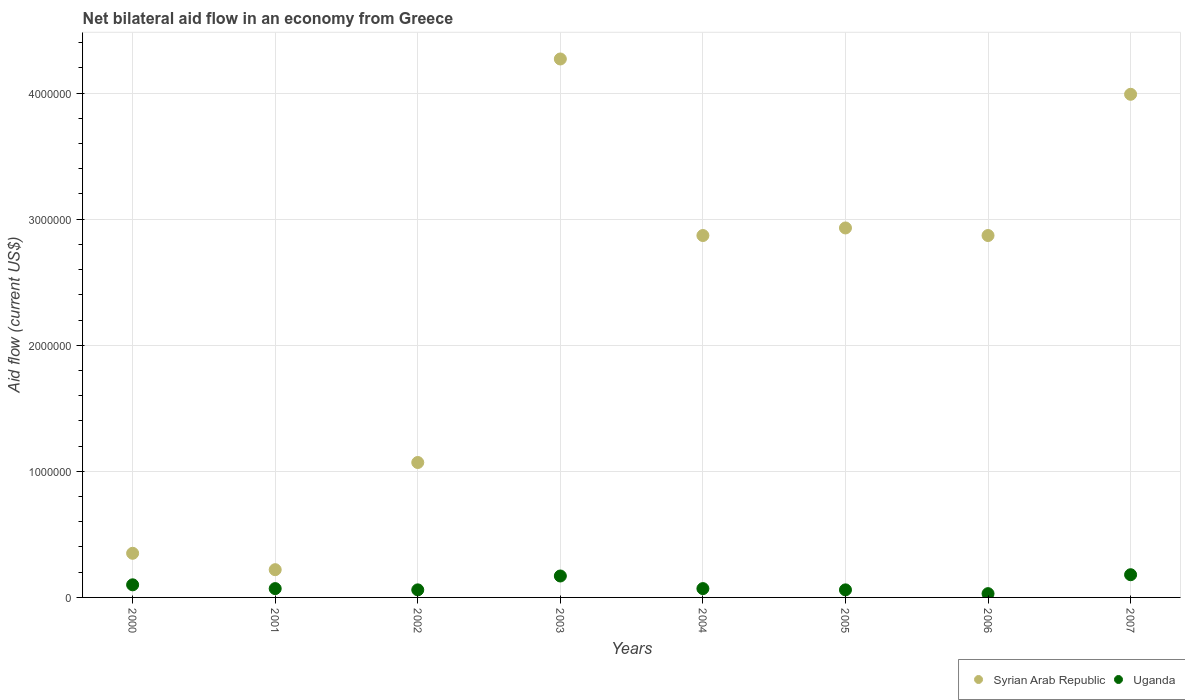How many different coloured dotlines are there?
Give a very brief answer. 2. What is the net bilateral aid flow in Syrian Arab Republic in 2007?
Ensure brevity in your answer.  3.99e+06. Across all years, what is the maximum net bilateral aid flow in Uganda?
Provide a short and direct response. 1.80e+05. In which year was the net bilateral aid flow in Uganda maximum?
Give a very brief answer. 2007. What is the total net bilateral aid flow in Syrian Arab Republic in the graph?
Keep it short and to the point. 1.86e+07. What is the difference between the net bilateral aid flow in Uganda in 2000 and that in 2002?
Ensure brevity in your answer.  4.00e+04. What is the difference between the net bilateral aid flow in Uganda in 2002 and the net bilateral aid flow in Syrian Arab Republic in 2003?
Give a very brief answer. -4.21e+06. What is the average net bilateral aid flow in Uganda per year?
Make the answer very short. 9.25e+04. In the year 2003, what is the difference between the net bilateral aid flow in Uganda and net bilateral aid flow in Syrian Arab Republic?
Offer a terse response. -4.10e+06. In how many years, is the net bilateral aid flow in Syrian Arab Republic greater than 3600000 US$?
Offer a terse response. 2. What is the ratio of the net bilateral aid flow in Syrian Arab Republic in 2005 to that in 2007?
Offer a very short reply. 0.73. Is the net bilateral aid flow in Syrian Arab Republic in 2004 less than that in 2006?
Offer a very short reply. No. What is the difference between the highest and the lowest net bilateral aid flow in Syrian Arab Republic?
Provide a short and direct response. 4.05e+06. Is the sum of the net bilateral aid flow in Syrian Arab Republic in 2004 and 2005 greater than the maximum net bilateral aid flow in Uganda across all years?
Keep it short and to the point. Yes. Are the values on the major ticks of Y-axis written in scientific E-notation?
Keep it short and to the point. No. Does the graph contain any zero values?
Ensure brevity in your answer.  No. Where does the legend appear in the graph?
Your answer should be compact. Bottom right. What is the title of the graph?
Keep it short and to the point. Net bilateral aid flow in an economy from Greece. What is the label or title of the Y-axis?
Your answer should be compact. Aid flow (current US$). What is the Aid flow (current US$) in Syrian Arab Republic in 2000?
Ensure brevity in your answer.  3.50e+05. What is the Aid flow (current US$) in Uganda in 2000?
Make the answer very short. 1.00e+05. What is the Aid flow (current US$) of Uganda in 2001?
Your answer should be compact. 7.00e+04. What is the Aid flow (current US$) of Syrian Arab Republic in 2002?
Give a very brief answer. 1.07e+06. What is the Aid flow (current US$) in Syrian Arab Republic in 2003?
Offer a terse response. 4.27e+06. What is the Aid flow (current US$) of Syrian Arab Republic in 2004?
Give a very brief answer. 2.87e+06. What is the Aid flow (current US$) in Uganda in 2004?
Provide a succinct answer. 7.00e+04. What is the Aid flow (current US$) of Syrian Arab Republic in 2005?
Provide a short and direct response. 2.93e+06. What is the Aid flow (current US$) of Syrian Arab Republic in 2006?
Make the answer very short. 2.87e+06. What is the Aid flow (current US$) of Syrian Arab Republic in 2007?
Give a very brief answer. 3.99e+06. Across all years, what is the maximum Aid flow (current US$) in Syrian Arab Republic?
Provide a succinct answer. 4.27e+06. Across all years, what is the minimum Aid flow (current US$) in Syrian Arab Republic?
Offer a very short reply. 2.20e+05. Across all years, what is the minimum Aid flow (current US$) of Uganda?
Provide a short and direct response. 3.00e+04. What is the total Aid flow (current US$) of Syrian Arab Republic in the graph?
Offer a very short reply. 1.86e+07. What is the total Aid flow (current US$) in Uganda in the graph?
Provide a succinct answer. 7.40e+05. What is the difference between the Aid flow (current US$) of Syrian Arab Republic in 2000 and that in 2002?
Your response must be concise. -7.20e+05. What is the difference between the Aid flow (current US$) in Uganda in 2000 and that in 2002?
Give a very brief answer. 4.00e+04. What is the difference between the Aid flow (current US$) of Syrian Arab Republic in 2000 and that in 2003?
Give a very brief answer. -3.92e+06. What is the difference between the Aid flow (current US$) of Uganda in 2000 and that in 2003?
Your response must be concise. -7.00e+04. What is the difference between the Aid flow (current US$) of Syrian Arab Republic in 2000 and that in 2004?
Keep it short and to the point. -2.52e+06. What is the difference between the Aid flow (current US$) of Syrian Arab Republic in 2000 and that in 2005?
Offer a terse response. -2.58e+06. What is the difference between the Aid flow (current US$) of Syrian Arab Republic in 2000 and that in 2006?
Make the answer very short. -2.52e+06. What is the difference between the Aid flow (current US$) of Syrian Arab Republic in 2000 and that in 2007?
Your response must be concise. -3.64e+06. What is the difference between the Aid flow (current US$) of Uganda in 2000 and that in 2007?
Your response must be concise. -8.00e+04. What is the difference between the Aid flow (current US$) of Syrian Arab Republic in 2001 and that in 2002?
Offer a very short reply. -8.50e+05. What is the difference between the Aid flow (current US$) of Uganda in 2001 and that in 2002?
Offer a very short reply. 10000. What is the difference between the Aid flow (current US$) of Syrian Arab Republic in 2001 and that in 2003?
Provide a succinct answer. -4.05e+06. What is the difference between the Aid flow (current US$) in Uganda in 2001 and that in 2003?
Offer a very short reply. -1.00e+05. What is the difference between the Aid flow (current US$) in Syrian Arab Republic in 2001 and that in 2004?
Make the answer very short. -2.65e+06. What is the difference between the Aid flow (current US$) in Syrian Arab Republic in 2001 and that in 2005?
Your answer should be compact. -2.71e+06. What is the difference between the Aid flow (current US$) in Syrian Arab Republic in 2001 and that in 2006?
Make the answer very short. -2.65e+06. What is the difference between the Aid flow (current US$) in Syrian Arab Republic in 2001 and that in 2007?
Provide a short and direct response. -3.77e+06. What is the difference between the Aid flow (current US$) in Uganda in 2001 and that in 2007?
Offer a very short reply. -1.10e+05. What is the difference between the Aid flow (current US$) of Syrian Arab Republic in 2002 and that in 2003?
Provide a short and direct response. -3.20e+06. What is the difference between the Aid flow (current US$) in Syrian Arab Republic in 2002 and that in 2004?
Ensure brevity in your answer.  -1.80e+06. What is the difference between the Aid flow (current US$) in Uganda in 2002 and that in 2004?
Keep it short and to the point. -10000. What is the difference between the Aid flow (current US$) in Syrian Arab Republic in 2002 and that in 2005?
Your answer should be very brief. -1.86e+06. What is the difference between the Aid flow (current US$) in Uganda in 2002 and that in 2005?
Your answer should be compact. 0. What is the difference between the Aid flow (current US$) in Syrian Arab Republic in 2002 and that in 2006?
Make the answer very short. -1.80e+06. What is the difference between the Aid flow (current US$) in Syrian Arab Republic in 2002 and that in 2007?
Your answer should be very brief. -2.92e+06. What is the difference between the Aid flow (current US$) of Syrian Arab Republic in 2003 and that in 2004?
Offer a terse response. 1.40e+06. What is the difference between the Aid flow (current US$) in Syrian Arab Republic in 2003 and that in 2005?
Offer a very short reply. 1.34e+06. What is the difference between the Aid flow (current US$) in Syrian Arab Republic in 2003 and that in 2006?
Offer a very short reply. 1.40e+06. What is the difference between the Aid flow (current US$) of Uganda in 2003 and that in 2007?
Ensure brevity in your answer.  -10000. What is the difference between the Aid flow (current US$) in Uganda in 2004 and that in 2005?
Offer a very short reply. 10000. What is the difference between the Aid flow (current US$) of Syrian Arab Republic in 2004 and that in 2006?
Your answer should be very brief. 0. What is the difference between the Aid flow (current US$) in Syrian Arab Republic in 2004 and that in 2007?
Provide a succinct answer. -1.12e+06. What is the difference between the Aid flow (current US$) of Uganda in 2004 and that in 2007?
Your answer should be very brief. -1.10e+05. What is the difference between the Aid flow (current US$) in Syrian Arab Republic in 2005 and that in 2007?
Your response must be concise. -1.06e+06. What is the difference between the Aid flow (current US$) of Uganda in 2005 and that in 2007?
Ensure brevity in your answer.  -1.20e+05. What is the difference between the Aid flow (current US$) of Syrian Arab Republic in 2006 and that in 2007?
Provide a succinct answer. -1.12e+06. What is the difference between the Aid flow (current US$) of Syrian Arab Republic in 2000 and the Aid flow (current US$) of Uganda in 2007?
Keep it short and to the point. 1.70e+05. What is the difference between the Aid flow (current US$) in Syrian Arab Republic in 2001 and the Aid flow (current US$) in Uganda in 2003?
Give a very brief answer. 5.00e+04. What is the difference between the Aid flow (current US$) in Syrian Arab Republic in 2001 and the Aid flow (current US$) in Uganda in 2005?
Give a very brief answer. 1.60e+05. What is the difference between the Aid flow (current US$) of Syrian Arab Republic in 2001 and the Aid flow (current US$) of Uganda in 2006?
Offer a very short reply. 1.90e+05. What is the difference between the Aid flow (current US$) of Syrian Arab Republic in 2001 and the Aid flow (current US$) of Uganda in 2007?
Keep it short and to the point. 4.00e+04. What is the difference between the Aid flow (current US$) in Syrian Arab Republic in 2002 and the Aid flow (current US$) in Uganda in 2005?
Your answer should be compact. 1.01e+06. What is the difference between the Aid flow (current US$) in Syrian Arab Republic in 2002 and the Aid flow (current US$) in Uganda in 2006?
Your answer should be compact. 1.04e+06. What is the difference between the Aid flow (current US$) of Syrian Arab Republic in 2002 and the Aid flow (current US$) of Uganda in 2007?
Provide a succinct answer. 8.90e+05. What is the difference between the Aid flow (current US$) in Syrian Arab Republic in 2003 and the Aid flow (current US$) in Uganda in 2004?
Make the answer very short. 4.20e+06. What is the difference between the Aid flow (current US$) of Syrian Arab Republic in 2003 and the Aid flow (current US$) of Uganda in 2005?
Give a very brief answer. 4.21e+06. What is the difference between the Aid flow (current US$) in Syrian Arab Republic in 2003 and the Aid flow (current US$) in Uganda in 2006?
Your response must be concise. 4.24e+06. What is the difference between the Aid flow (current US$) in Syrian Arab Republic in 2003 and the Aid flow (current US$) in Uganda in 2007?
Your answer should be compact. 4.09e+06. What is the difference between the Aid flow (current US$) in Syrian Arab Republic in 2004 and the Aid flow (current US$) in Uganda in 2005?
Ensure brevity in your answer.  2.81e+06. What is the difference between the Aid flow (current US$) in Syrian Arab Republic in 2004 and the Aid flow (current US$) in Uganda in 2006?
Offer a very short reply. 2.84e+06. What is the difference between the Aid flow (current US$) of Syrian Arab Republic in 2004 and the Aid flow (current US$) of Uganda in 2007?
Ensure brevity in your answer.  2.69e+06. What is the difference between the Aid flow (current US$) in Syrian Arab Republic in 2005 and the Aid flow (current US$) in Uganda in 2006?
Ensure brevity in your answer.  2.90e+06. What is the difference between the Aid flow (current US$) in Syrian Arab Republic in 2005 and the Aid flow (current US$) in Uganda in 2007?
Give a very brief answer. 2.75e+06. What is the difference between the Aid flow (current US$) in Syrian Arab Republic in 2006 and the Aid flow (current US$) in Uganda in 2007?
Keep it short and to the point. 2.69e+06. What is the average Aid flow (current US$) of Syrian Arab Republic per year?
Your answer should be compact. 2.32e+06. What is the average Aid flow (current US$) in Uganda per year?
Your response must be concise. 9.25e+04. In the year 2000, what is the difference between the Aid flow (current US$) of Syrian Arab Republic and Aid flow (current US$) of Uganda?
Offer a terse response. 2.50e+05. In the year 2002, what is the difference between the Aid flow (current US$) in Syrian Arab Republic and Aid flow (current US$) in Uganda?
Your answer should be compact. 1.01e+06. In the year 2003, what is the difference between the Aid flow (current US$) in Syrian Arab Republic and Aid flow (current US$) in Uganda?
Provide a short and direct response. 4.10e+06. In the year 2004, what is the difference between the Aid flow (current US$) in Syrian Arab Republic and Aid flow (current US$) in Uganda?
Provide a short and direct response. 2.80e+06. In the year 2005, what is the difference between the Aid flow (current US$) of Syrian Arab Republic and Aid flow (current US$) of Uganda?
Provide a succinct answer. 2.87e+06. In the year 2006, what is the difference between the Aid flow (current US$) of Syrian Arab Republic and Aid flow (current US$) of Uganda?
Keep it short and to the point. 2.84e+06. In the year 2007, what is the difference between the Aid flow (current US$) of Syrian Arab Republic and Aid flow (current US$) of Uganda?
Your response must be concise. 3.81e+06. What is the ratio of the Aid flow (current US$) of Syrian Arab Republic in 2000 to that in 2001?
Ensure brevity in your answer.  1.59. What is the ratio of the Aid flow (current US$) of Uganda in 2000 to that in 2001?
Offer a very short reply. 1.43. What is the ratio of the Aid flow (current US$) in Syrian Arab Republic in 2000 to that in 2002?
Keep it short and to the point. 0.33. What is the ratio of the Aid flow (current US$) in Uganda in 2000 to that in 2002?
Your answer should be compact. 1.67. What is the ratio of the Aid flow (current US$) in Syrian Arab Republic in 2000 to that in 2003?
Provide a short and direct response. 0.08. What is the ratio of the Aid flow (current US$) in Uganda in 2000 to that in 2003?
Your answer should be compact. 0.59. What is the ratio of the Aid flow (current US$) in Syrian Arab Republic in 2000 to that in 2004?
Ensure brevity in your answer.  0.12. What is the ratio of the Aid flow (current US$) in Uganda in 2000 to that in 2004?
Keep it short and to the point. 1.43. What is the ratio of the Aid flow (current US$) in Syrian Arab Republic in 2000 to that in 2005?
Provide a short and direct response. 0.12. What is the ratio of the Aid flow (current US$) of Syrian Arab Republic in 2000 to that in 2006?
Your response must be concise. 0.12. What is the ratio of the Aid flow (current US$) of Uganda in 2000 to that in 2006?
Provide a short and direct response. 3.33. What is the ratio of the Aid flow (current US$) in Syrian Arab Republic in 2000 to that in 2007?
Offer a very short reply. 0.09. What is the ratio of the Aid flow (current US$) in Uganda in 2000 to that in 2007?
Offer a terse response. 0.56. What is the ratio of the Aid flow (current US$) of Syrian Arab Republic in 2001 to that in 2002?
Offer a very short reply. 0.21. What is the ratio of the Aid flow (current US$) in Syrian Arab Republic in 2001 to that in 2003?
Ensure brevity in your answer.  0.05. What is the ratio of the Aid flow (current US$) in Uganda in 2001 to that in 2003?
Offer a very short reply. 0.41. What is the ratio of the Aid flow (current US$) of Syrian Arab Republic in 2001 to that in 2004?
Provide a succinct answer. 0.08. What is the ratio of the Aid flow (current US$) of Uganda in 2001 to that in 2004?
Your answer should be very brief. 1. What is the ratio of the Aid flow (current US$) of Syrian Arab Republic in 2001 to that in 2005?
Offer a very short reply. 0.08. What is the ratio of the Aid flow (current US$) of Uganda in 2001 to that in 2005?
Your answer should be very brief. 1.17. What is the ratio of the Aid flow (current US$) of Syrian Arab Republic in 2001 to that in 2006?
Give a very brief answer. 0.08. What is the ratio of the Aid flow (current US$) in Uganda in 2001 to that in 2006?
Your response must be concise. 2.33. What is the ratio of the Aid flow (current US$) in Syrian Arab Republic in 2001 to that in 2007?
Provide a succinct answer. 0.06. What is the ratio of the Aid flow (current US$) in Uganda in 2001 to that in 2007?
Provide a short and direct response. 0.39. What is the ratio of the Aid flow (current US$) in Syrian Arab Republic in 2002 to that in 2003?
Provide a short and direct response. 0.25. What is the ratio of the Aid flow (current US$) in Uganda in 2002 to that in 2003?
Provide a short and direct response. 0.35. What is the ratio of the Aid flow (current US$) in Syrian Arab Republic in 2002 to that in 2004?
Make the answer very short. 0.37. What is the ratio of the Aid flow (current US$) of Uganda in 2002 to that in 2004?
Ensure brevity in your answer.  0.86. What is the ratio of the Aid flow (current US$) of Syrian Arab Republic in 2002 to that in 2005?
Your answer should be compact. 0.37. What is the ratio of the Aid flow (current US$) in Syrian Arab Republic in 2002 to that in 2006?
Keep it short and to the point. 0.37. What is the ratio of the Aid flow (current US$) in Uganda in 2002 to that in 2006?
Your answer should be very brief. 2. What is the ratio of the Aid flow (current US$) in Syrian Arab Republic in 2002 to that in 2007?
Offer a very short reply. 0.27. What is the ratio of the Aid flow (current US$) of Syrian Arab Republic in 2003 to that in 2004?
Your answer should be very brief. 1.49. What is the ratio of the Aid flow (current US$) of Uganda in 2003 to that in 2004?
Make the answer very short. 2.43. What is the ratio of the Aid flow (current US$) in Syrian Arab Republic in 2003 to that in 2005?
Provide a short and direct response. 1.46. What is the ratio of the Aid flow (current US$) in Uganda in 2003 to that in 2005?
Your response must be concise. 2.83. What is the ratio of the Aid flow (current US$) in Syrian Arab Republic in 2003 to that in 2006?
Give a very brief answer. 1.49. What is the ratio of the Aid flow (current US$) of Uganda in 2003 to that in 2006?
Ensure brevity in your answer.  5.67. What is the ratio of the Aid flow (current US$) in Syrian Arab Republic in 2003 to that in 2007?
Your response must be concise. 1.07. What is the ratio of the Aid flow (current US$) in Syrian Arab Republic in 2004 to that in 2005?
Offer a terse response. 0.98. What is the ratio of the Aid flow (current US$) in Uganda in 2004 to that in 2006?
Make the answer very short. 2.33. What is the ratio of the Aid flow (current US$) in Syrian Arab Republic in 2004 to that in 2007?
Your response must be concise. 0.72. What is the ratio of the Aid flow (current US$) in Uganda in 2004 to that in 2007?
Give a very brief answer. 0.39. What is the ratio of the Aid flow (current US$) in Syrian Arab Republic in 2005 to that in 2006?
Provide a succinct answer. 1.02. What is the ratio of the Aid flow (current US$) in Uganda in 2005 to that in 2006?
Your answer should be compact. 2. What is the ratio of the Aid flow (current US$) in Syrian Arab Republic in 2005 to that in 2007?
Your response must be concise. 0.73. What is the ratio of the Aid flow (current US$) of Syrian Arab Republic in 2006 to that in 2007?
Ensure brevity in your answer.  0.72. What is the ratio of the Aid flow (current US$) in Uganda in 2006 to that in 2007?
Offer a very short reply. 0.17. What is the difference between the highest and the second highest Aid flow (current US$) in Uganda?
Your answer should be compact. 10000. What is the difference between the highest and the lowest Aid flow (current US$) of Syrian Arab Republic?
Keep it short and to the point. 4.05e+06. 